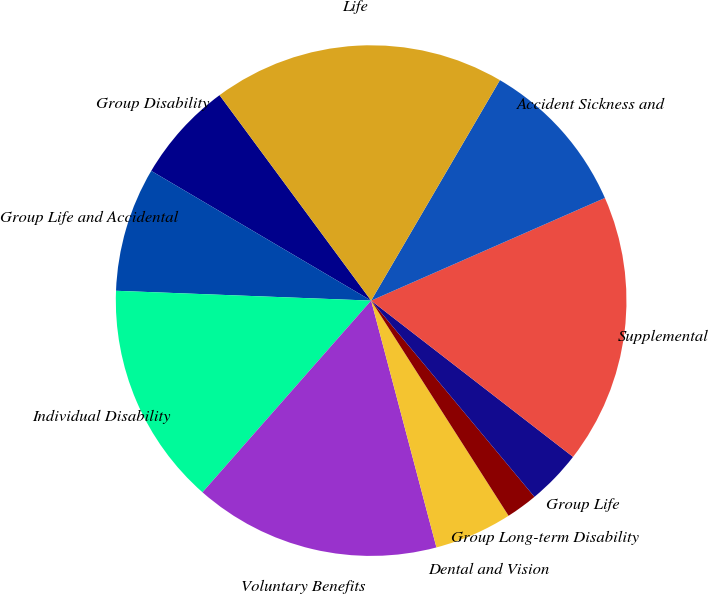Convert chart to OTSL. <chart><loc_0><loc_0><loc_500><loc_500><pie_chart><fcel>Group Disability<fcel>Group Life and Accidental<fcel>Individual Disability<fcel>Voluntary Benefits<fcel>Dental and Vision<fcel>Group Long-term Disability<fcel>Group Life<fcel>Supplemental<fcel>Accident Sickness and<fcel>Life<nl><fcel>6.4%<fcel>7.87%<fcel>14.13%<fcel>15.6%<fcel>4.93%<fcel>2.0%<fcel>3.47%<fcel>17.07%<fcel>10.0%<fcel>18.53%<nl></chart> 